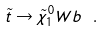Convert formula to latex. <formula><loc_0><loc_0><loc_500><loc_500>\tilde { t } \to \tilde { \chi } ^ { 0 } _ { 1 } W b \ .</formula> 